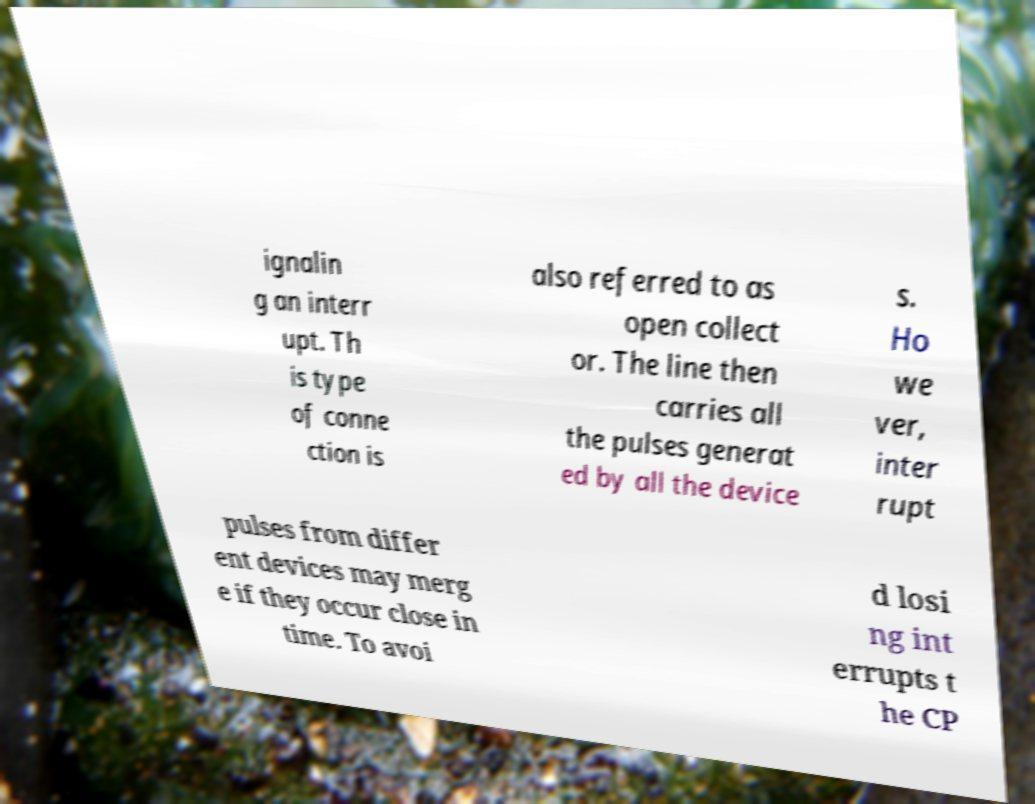Please identify and transcribe the text found in this image. ignalin g an interr upt. Th is type of conne ction is also referred to as open collect or. The line then carries all the pulses generat ed by all the device s. Ho we ver, inter rupt pulses from differ ent devices may merg e if they occur close in time. To avoi d losi ng int errupts t he CP 